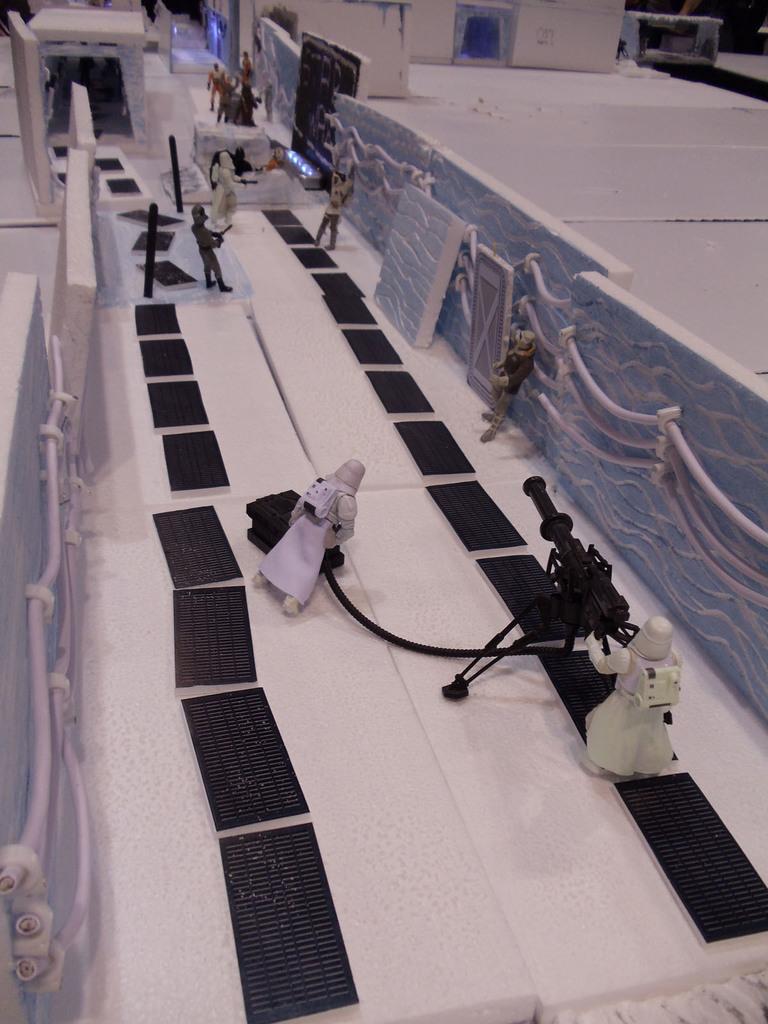How would you summarize this image in a sentence or two? In this picture, we see the toys which are holding some electronic goods. We see these toys are placed on the white table or thermocol. Beside that, we see an objects in black color which looks like the solar panels. On either side of the panels, we see the walls, which are made up of thermocol. We even see the railing and this wall is in blue color. In the background, we see a building in white color. This picture might be clicked in the science fair. 